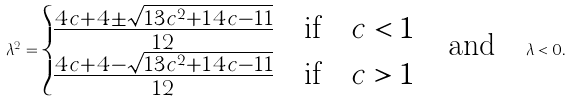<formula> <loc_0><loc_0><loc_500><loc_500>\lambda ^ { 2 } = \begin{cases} \frac { 4 c + 4 \pm \sqrt { 1 3 c ^ { 2 } + 1 4 c - 1 1 } } { 1 2 } & \text {if} \quad c < 1 \\ \frac { 4 c + 4 - \sqrt { 1 3 c ^ { 2 } + 1 4 c - 1 1 } } { 1 2 } & \text {if} \quad c > 1 \end{cases} \quad \text {and} \quad \lambda < 0 .</formula> 